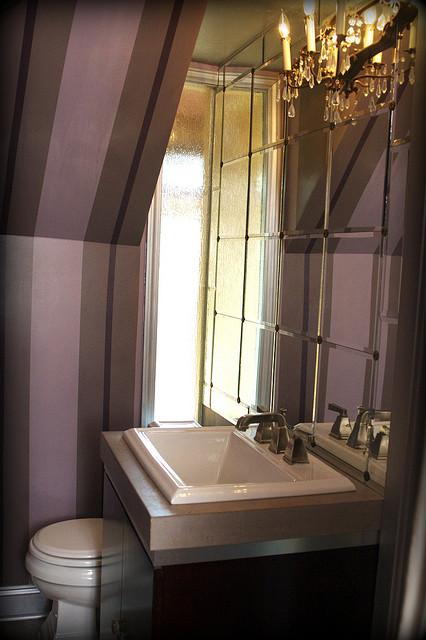What is the source of light in the picture?
Keep it brief. Window. Is the toilet lid up?
Answer briefly. No. How many sinks on the wall?
Concise answer only. 1. Was this photographed with a wide-angle lens?
Quick response, please. No. What color is the bathroom?
Be succinct. Purple. Are the candles real?
Answer briefly. No. Is this a large bathroom?
Keep it brief. No. 